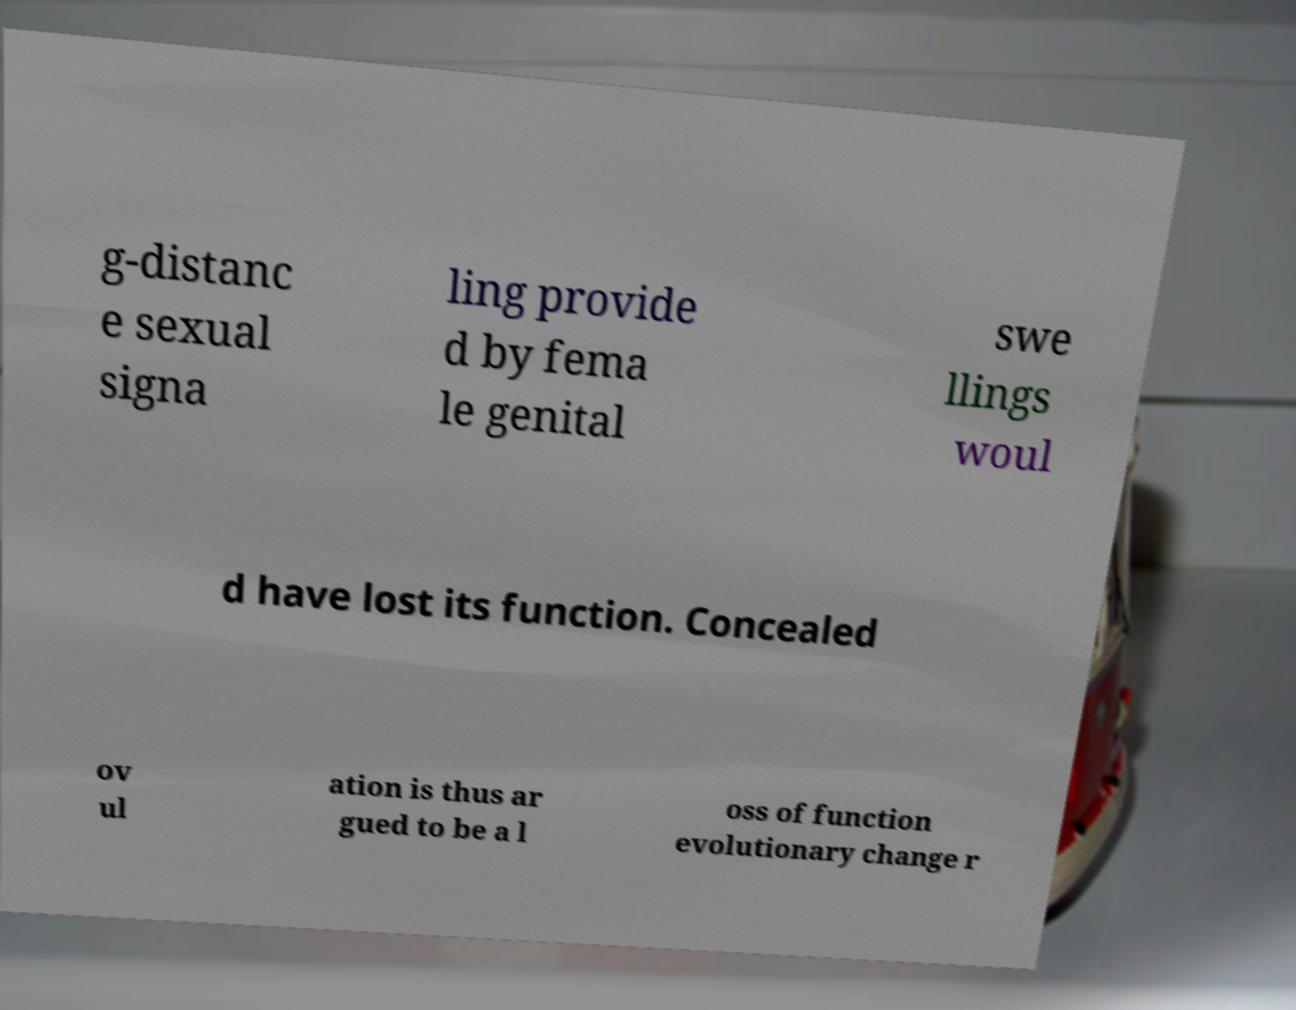There's text embedded in this image that I need extracted. Can you transcribe it verbatim? g-distanc e sexual signa ling provide d by fema le genital swe llings woul d have lost its function. Concealed ov ul ation is thus ar gued to be a l oss of function evolutionary change r 